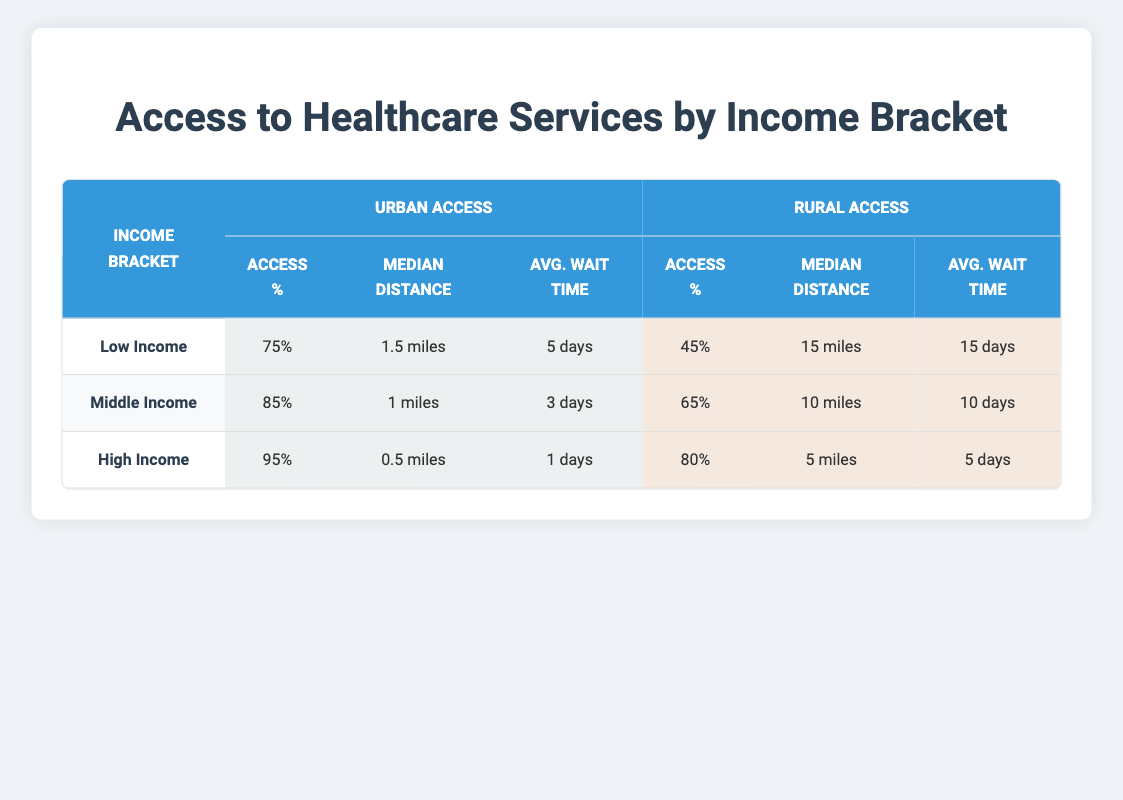What percentage of the low-income population has access to healthcare services in urban areas? According to the table, the urban access percentage for the low-income bracket is listed as 75%.
Answer: 75% What is the median distance to healthcare services for those in the middle-income bracket living in rural areas? The table shows that the median distance for middle-income individuals in rural areas is 10 miles.
Answer: 10 miles Is the average wait time for healthcare in urban areas shorter for high-income individuals compared to low-income individuals? The average wait time for high-income individuals in urban areas is 1 day, while for low-income individuals it is 5 days. Since 1 is less than 5, the statement is true.
Answer: Yes What is the difference in percentage of access to healthcare services between low-income individuals in urban and rural areas? Low-income individuals have 75% access in urban areas and 45% access in rural areas. The difference is calculated as 75 - 45 = 30%.
Answer: 30% Which income group has the highest access percentage to healthcare services in urban areas? The table indicates that the high-income group has the highest urban access percentage at 95%, compared to 85% for middle-income and 75% for low-income.
Answer: High Income Calculate the average wait time for healthcare services across all income brackets in urban areas. The average wait times for urban areas are as follows: low-income is 5 days, middle-income is 3 days, and high-income is 1 day. The total is 5 + 3 + 1 = 9 days. Dividing this by the number of groups (3) gives an average wait time of 9 / 3 = 3 days.
Answer: 3 days In rural areas, do middle-income individuals have better access to healthcare services than low-income individuals? Middle-income individuals have a rural access percentage of 65%, while low-income individuals have 45%. Since 65% is greater than 45%, the answer is yes.
Answer: Yes What is the average median distance to healthcare services for the high-income group across both urban and rural areas? For the high-income group, the median distance in urban areas is 0.5 miles, and in rural areas, it is 5 miles. The average is calculated as (0.5 + 5)/2 = 2.75 miles.
Answer: 2.75 miles What percentage of high-income individuals have access to healthcare services in rural areas? The table shows that 80% of high-income individuals have access to healthcare services in rural areas.
Answer: 80% 